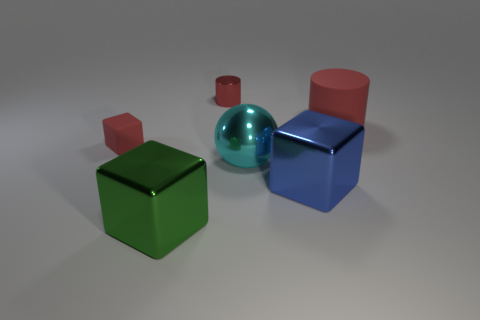Add 3 shiny blocks. How many objects exist? 9 Subtract 1 blocks. How many blocks are left? 2 Subtract all red blocks. How many blocks are left? 2 Subtract all big shiny cubes. How many cubes are left? 1 Subtract 1 cyan spheres. How many objects are left? 5 Subtract all balls. How many objects are left? 5 Subtract all gray balls. Subtract all green cylinders. How many balls are left? 1 Subtract all green blocks. How many gray spheres are left? 0 Subtract all big cyan metal things. Subtract all cyan things. How many objects are left? 4 Add 1 red cylinders. How many red cylinders are left? 3 